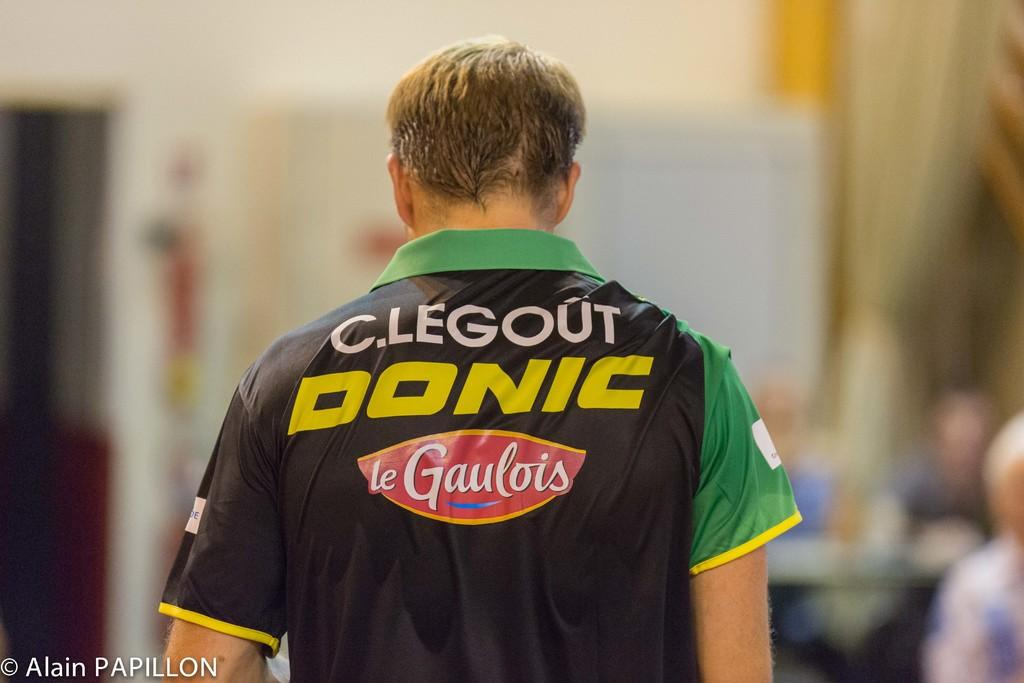<image>
Render a clear and concise summary of the photo. A man in a black and green shirt which has the word Donic in yellow. 